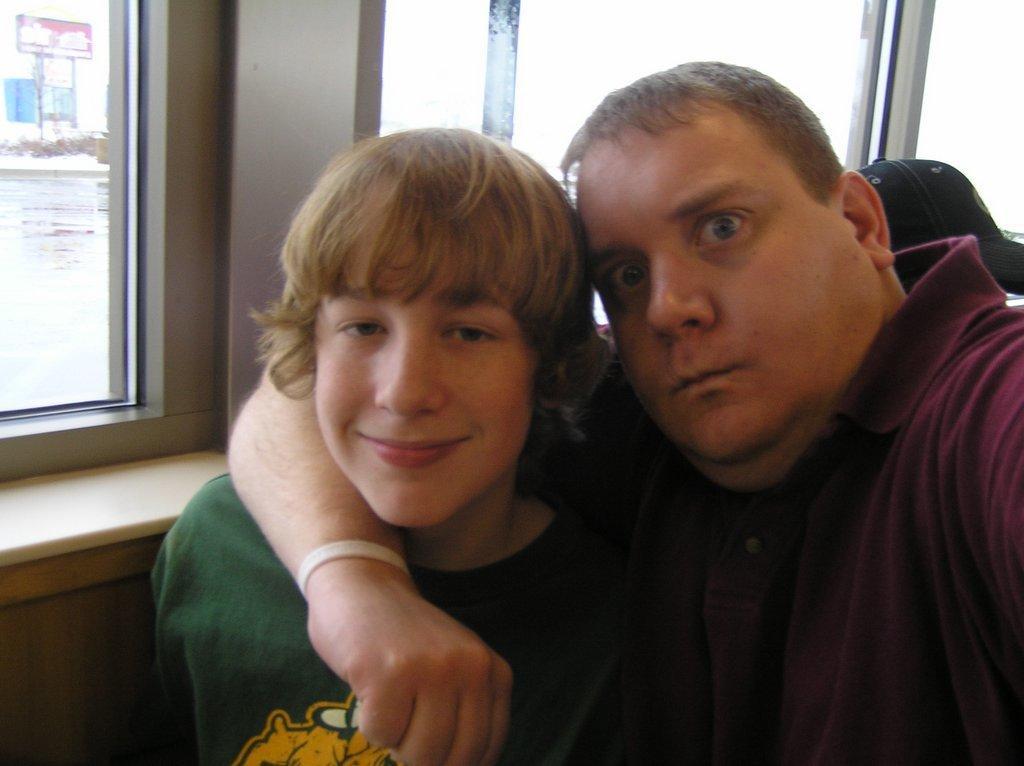Can you describe this image briefly? There is a man and a boy. In the back there are windows. Through the windows we can see water and some other items. 